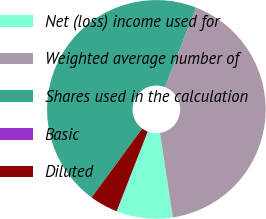Convert chart. <chart><loc_0><loc_0><loc_500><loc_500><pie_chart><fcel>Net (loss) income used for<fcel>Weighted average number of<fcel>Shares used in the calculation<fcel>Basic<fcel>Diluted<nl><fcel>8.33%<fcel>41.67%<fcel>45.83%<fcel>0.0%<fcel>4.17%<nl></chart> 